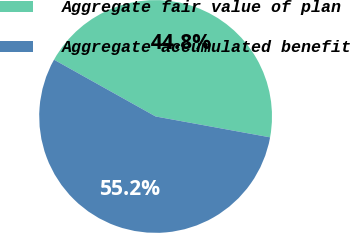Convert chart. <chart><loc_0><loc_0><loc_500><loc_500><pie_chart><fcel>Aggregate fair value of plan<fcel>Aggregate accumulated benefit<nl><fcel>44.76%<fcel>55.24%<nl></chart> 